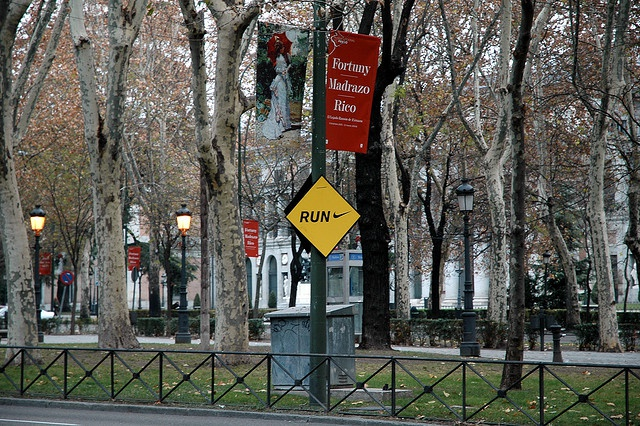Describe the objects in this image and their specific colors. I can see various objects in this image with different colors. 